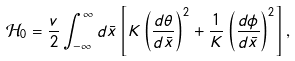<formula> <loc_0><loc_0><loc_500><loc_500>\mathcal { H } _ { 0 } = \frac { v } { 2 } \int ^ { \infty } _ { - \infty } d { \bar { x } } \left [ K \left ( \frac { d \theta } { d { \bar { x } } } \right ) ^ { 2 } + \frac { 1 } { K } \left ( \frac { d \phi } { d { \bar { x } } } \right ) ^ { 2 } \right ] ,</formula> 